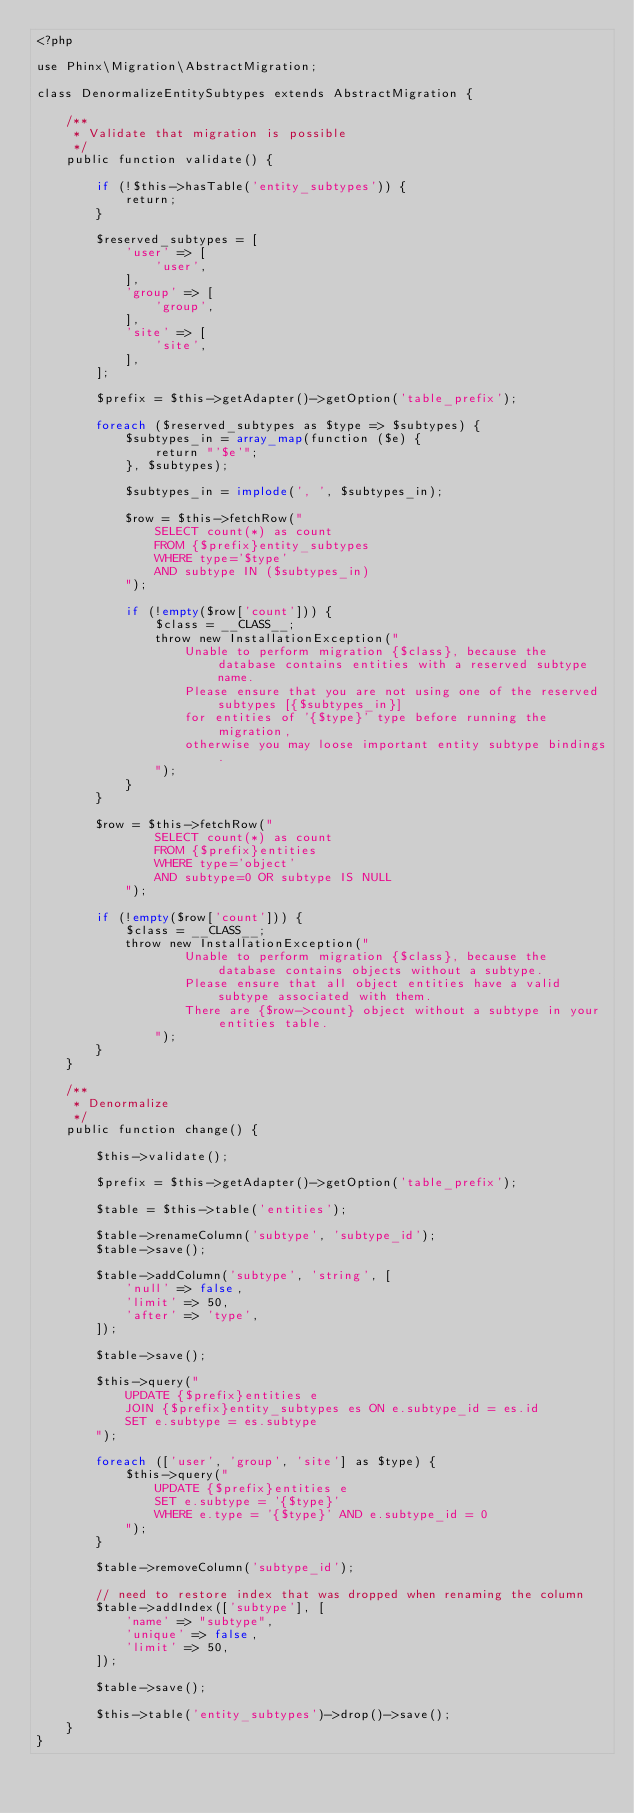Convert code to text. <code><loc_0><loc_0><loc_500><loc_500><_PHP_><?php

use Phinx\Migration\AbstractMigration;

class DenormalizeEntitySubtypes extends AbstractMigration {

	/**
	 * Validate that migration is possible
	 */
	public function validate() {

		if (!$this->hasTable('entity_subtypes')) {
			return;
		}

		$reserved_subtypes = [
			'user' => [
				'user',
			],
			'group' => [
				'group',
			],
			'site' => [
				'site',
			],
		];

		$prefix = $this->getAdapter()->getOption('table_prefix');

		foreach ($reserved_subtypes as $type => $subtypes) {
			$subtypes_in = array_map(function ($e) {
				return "'$e'";
			}, $subtypes);

			$subtypes_in = implode(', ', $subtypes_in);

			$row = $this->fetchRow("
				SELECT count(*) as count
				FROM {$prefix}entity_subtypes
				WHERE type='$type'
				AND subtype IN ($subtypes_in)
			");

			if (!empty($row['count'])) {
				$class = __CLASS__;
				throw new InstallationException("
					Unable to perform migration {$class}, because the database contains entities with a reserved subtype name.
					Please ensure that you are not using one of the reserved subtypes [{$subtypes_in}]
					for entities of '{$type}' type before running the migration,
					otherwise you may loose important entity subtype bindings.
				");
			}
		}

		$row = $this->fetchRow("
				SELECT count(*) as count
				FROM {$prefix}entities
				WHERE type='object'
				AND subtype=0 OR subtype IS NULL
			");

		if (!empty($row['count'])) {
			$class = __CLASS__;
			throw new InstallationException("
					Unable to perform migration {$class}, because the database contains objects without a subtype.
					Please ensure that all object entities have a valid subtype associated with them.
					There are {$row->count} object without a subtype in your entities table.
				");
		}
	}

	/**
	 * Denormalize
	 */
	public function change() {

		$this->validate();

		$prefix = $this->getAdapter()->getOption('table_prefix');

		$table = $this->table('entities');

		$table->renameColumn('subtype', 'subtype_id');
		$table->save();

		$table->addColumn('subtype', 'string', [
			'null' => false,
			'limit' => 50,
			'after' => 'type',
		]);
				
		$table->save();

		$this->query("
			UPDATE {$prefix}entities e
			JOIN {$prefix}entity_subtypes es ON e.subtype_id = es.id
			SET e.subtype = es.subtype
		");

		foreach (['user', 'group', 'site'] as $type) {
			$this->query("
				UPDATE {$prefix}entities e
				SET e.subtype = '{$type}'
				WHERE e.type = '{$type}' AND e.subtype_id = 0
			");
		}

		$table->removeColumn('subtype_id');
		
		// need to restore index that was dropped when renaming the column
		$table->addIndex(['subtype'], [
			'name' => "subtype",
			'unique' => false,
			'limit' => 50,
		]);
		
		$table->save();

		$this->table('entity_subtypes')->drop()->save();
	}
}
</code> 